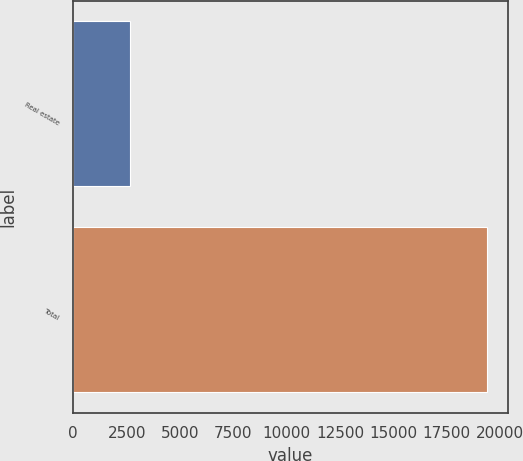<chart> <loc_0><loc_0><loc_500><loc_500><bar_chart><fcel>Real estate<fcel>Total<nl><fcel>2659<fcel>19399<nl></chart> 